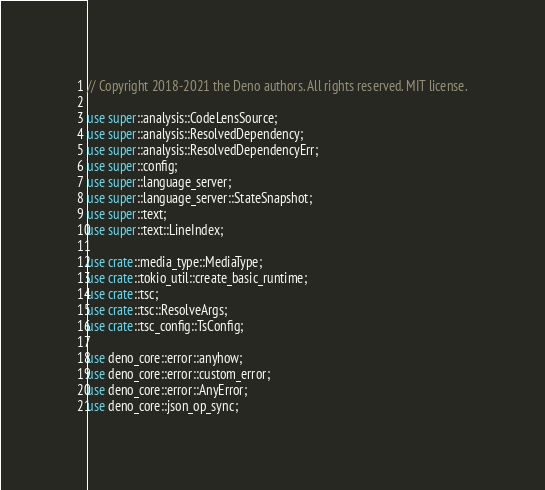<code> <loc_0><loc_0><loc_500><loc_500><_Rust_>// Copyright 2018-2021 the Deno authors. All rights reserved. MIT license.

use super::analysis::CodeLensSource;
use super::analysis::ResolvedDependency;
use super::analysis::ResolvedDependencyErr;
use super::config;
use super::language_server;
use super::language_server::StateSnapshot;
use super::text;
use super::text::LineIndex;

use crate::media_type::MediaType;
use crate::tokio_util::create_basic_runtime;
use crate::tsc;
use crate::tsc::ResolveArgs;
use crate::tsc_config::TsConfig;

use deno_core::error::anyhow;
use deno_core::error::custom_error;
use deno_core::error::AnyError;
use deno_core::json_op_sync;</code> 